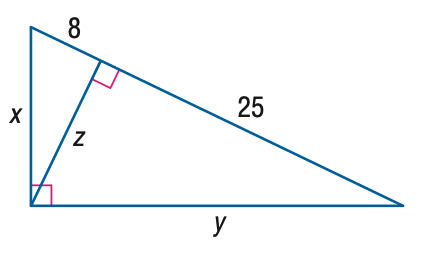Answer the mathemtical geometry problem and directly provide the correct option letter.
Question: Find x.
Choices: A: 8 B: 2 \sqrt { 34 } C: 10 \sqrt { 2 } D: 2 \sqrt { 66 } D 